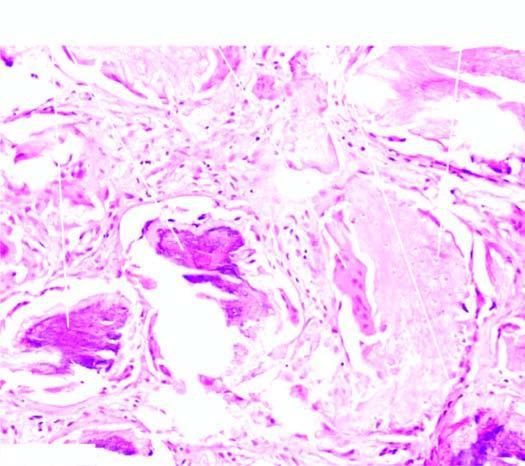what are also seen?
Answer the question using a single word or phrase. Areas of calcification 